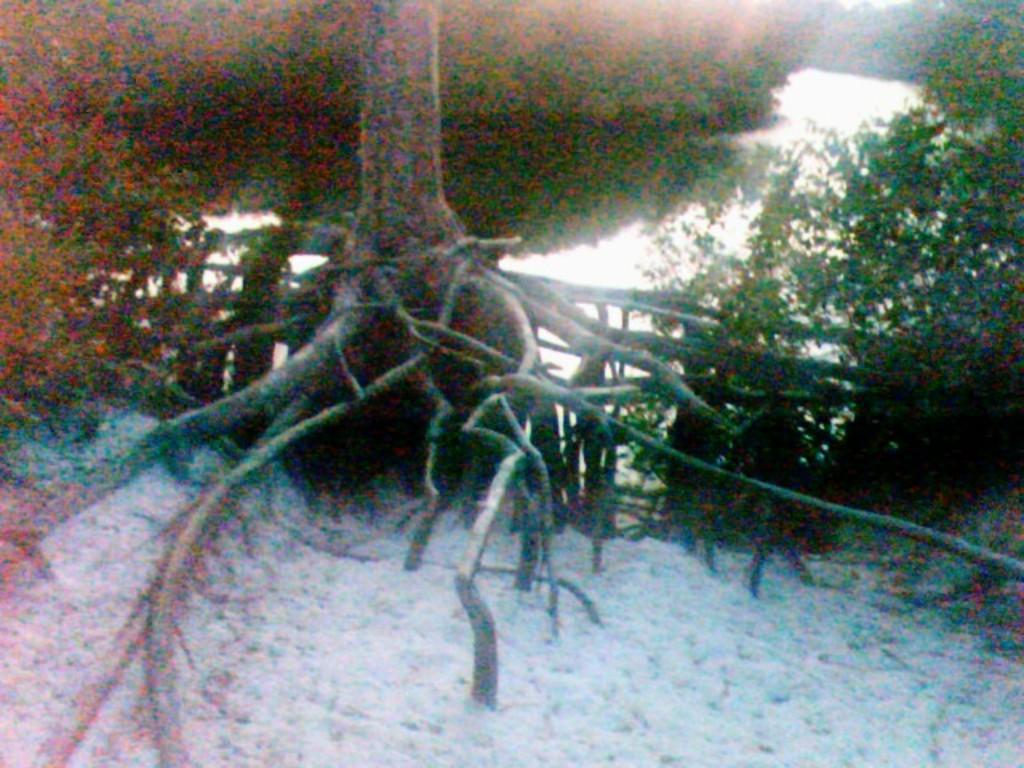What type of weather condition is depicted at the bottom of the image? There is snow at the bottom of the image. What can be seen in the background of the image? There are trees in the background of the image. What part of a tree can be seen in the image? There are roots of a tree visible in the image. What type of rhythm can be heard in the image? There is no sound or rhythm present in the image, as it is a still picture. 